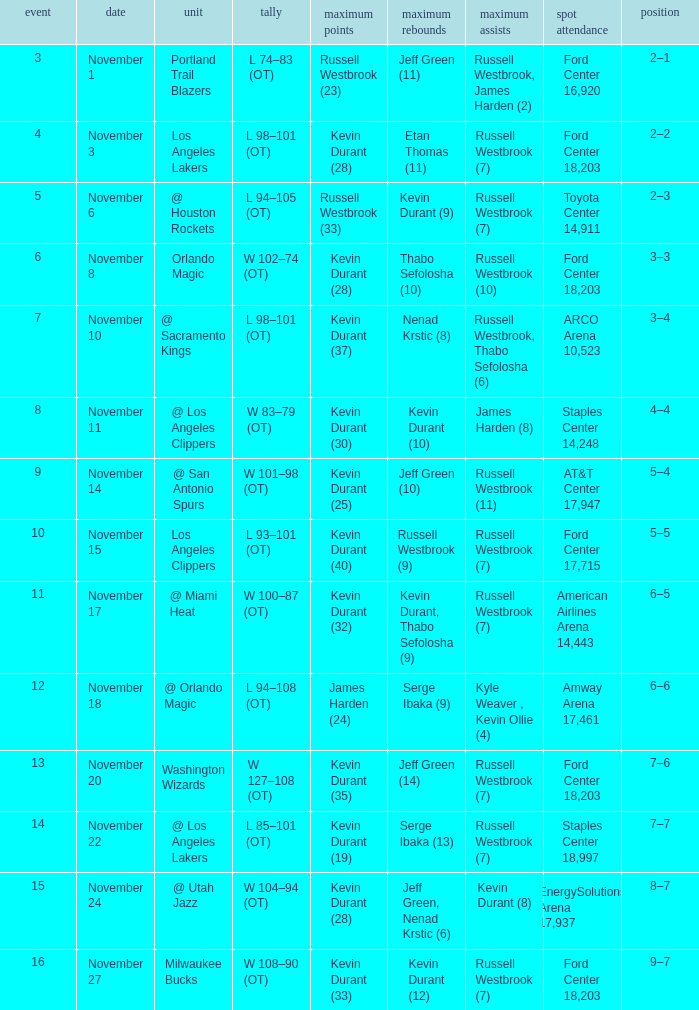What was the record in the game in which Jeff Green (14) did the most high rebounds? 7–6. 